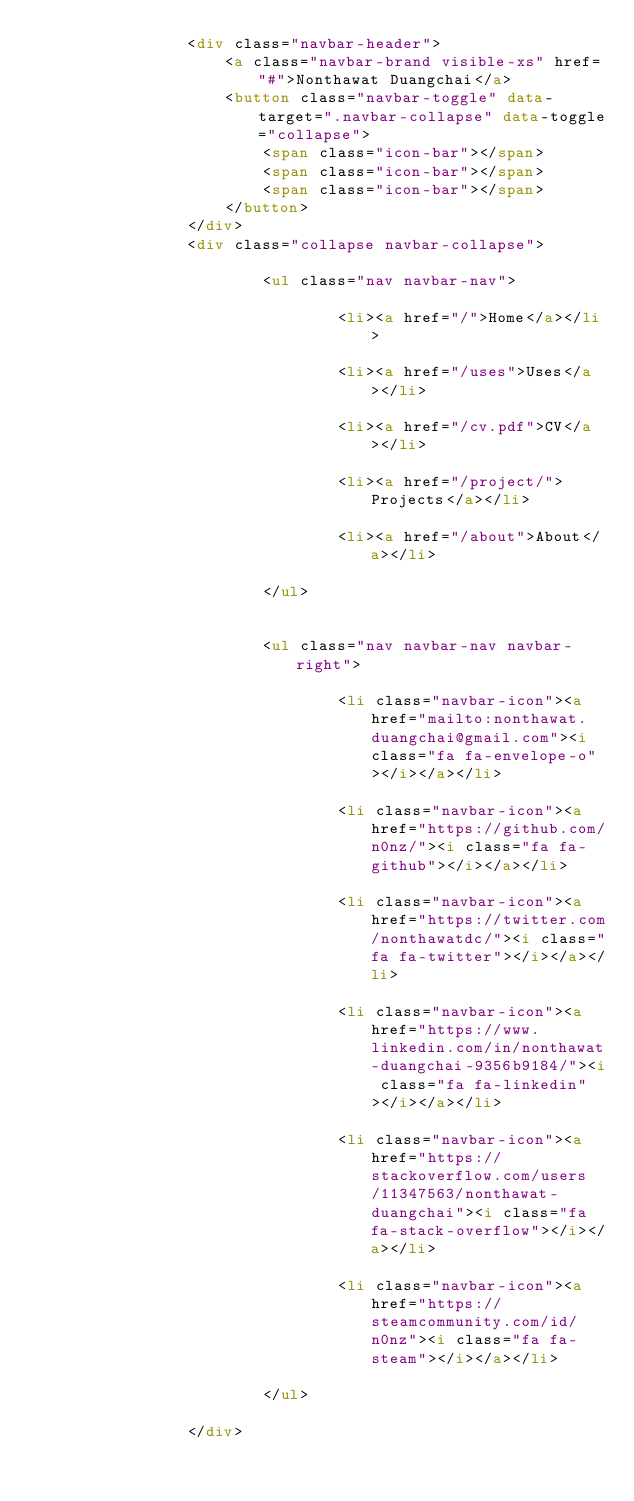<code> <loc_0><loc_0><loc_500><loc_500><_HTML_>                <div class="navbar-header">
                    <a class="navbar-brand visible-xs" href="#">Nonthawat Duangchai</a>
                    <button class="navbar-toggle" data-target=".navbar-collapse" data-toggle="collapse">
                        <span class="icon-bar"></span>
                        <span class="icon-bar"></span>
                        <span class="icon-bar"></span>
                    </button>
                </div>
                <div class="collapse navbar-collapse">
                    
                        <ul class="nav navbar-nav">
                            
                                <li><a href="/">Home</a></li>
                            
                                <li><a href="/uses">Uses</a></li>
                            
                                <li><a href="/cv.pdf">CV</a></li>
                            
                                <li><a href="/project/">Projects</a></li>
                            
                                <li><a href="/about">About</a></li>
                            
                        </ul>
                    
                    
                        <ul class="nav navbar-nav navbar-right">
                            
                                <li class="navbar-icon"><a href="mailto:nonthawat.duangchai@gmail.com"><i class="fa fa-envelope-o"></i></a></li>
                            
                                <li class="navbar-icon"><a href="https://github.com/n0nz/"><i class="fa fa-github"></i></a></li>
                            
                                <li class="navbar-icon"><a href="https://twitter.com/nonthawatdc/"><i class="fa fa-twitter"></i></a></li>
                            
                                <li class="navbar-icon"><a href="https://www.linkedin.com/in/nonthawat-duangchai-9356b9184/"><i class="fa fa-linkedin"></i></a></li>
                            
                                <li class="navbar-icon"><a href="https://stackoverflow.com/users/11347563/nonthawat-duangchai"><i class="fa fa-stack-overflow"></i></a></li>
                            
                                <li class="navbar-icon"><a href="https://steamcommunity.com/id/n0nz"><i class="fa fa-steam"></i></a></li>
                            
                        </ul>
                    
                </div></code> 